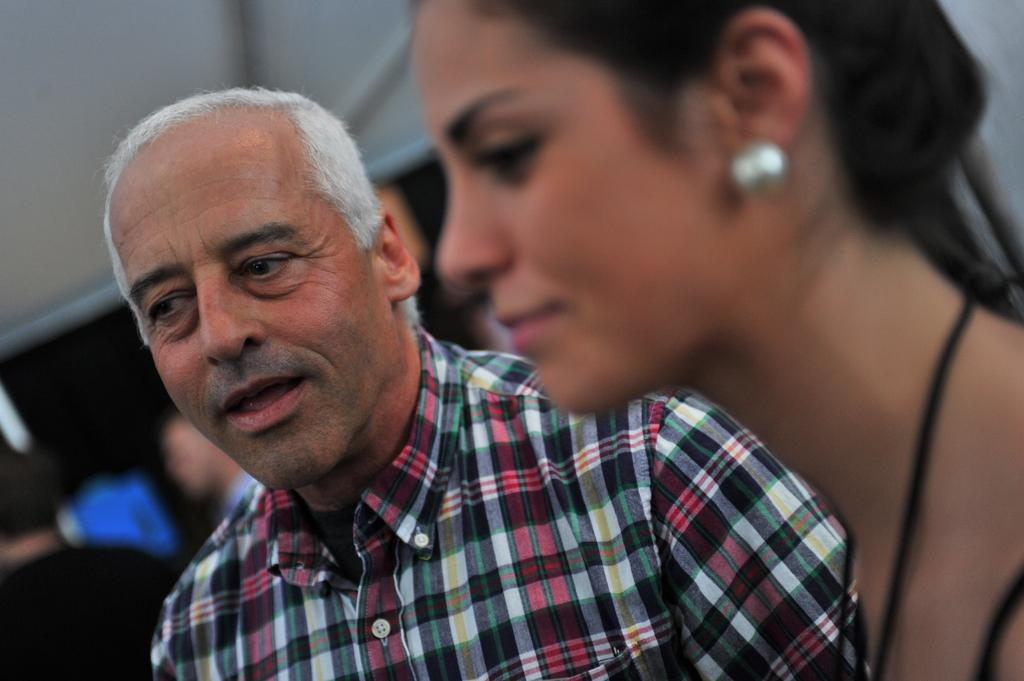What part of the image is blurred? The right side of the image is blurred. Who is located on the right side of the image? There is a woman on the right side of the image. Who is in the center of the image? There is a person in the center of the image. What can be seen in the background of the image? The background of the image is blurred, and there are people and a tent in the background. What type of gold design can be seen on the woman's sack in the image? There is no sack or gold design present in the image. 